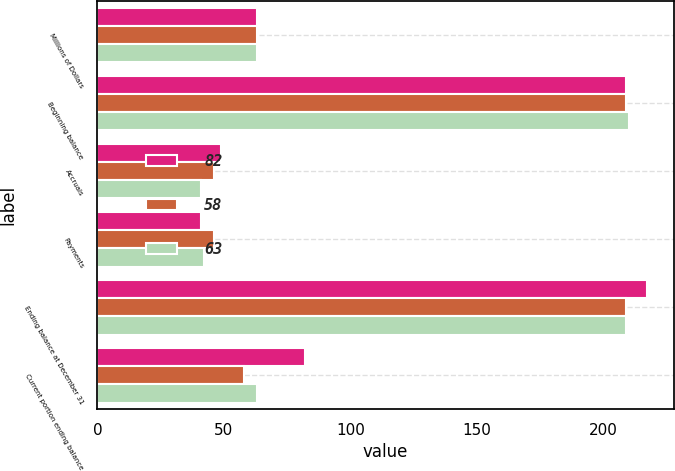<chart> <loc_0><loc_0><loc_500><loc_500><stacked_bar_chart><ecel><fcel>Millions of Dollars<fcel>Beginning balance<fcel>Accruals<fcel>Payments<fcel>Ending balance at December 31<fcel>Current portion ending balance<nl><fcel>82<fcel>63<fcel>209<fcel>49<fcel>41<fcel>217<fcel>82<nl><fcel>58<fcel>63<fcel>209<fcel>46<fcel>46<fcel>209<fcel>58<nl><fcel>63<fcel>63<fcel>210<fcel>41<fcel>42<fcel>209<fcel>63<nl></chart> 